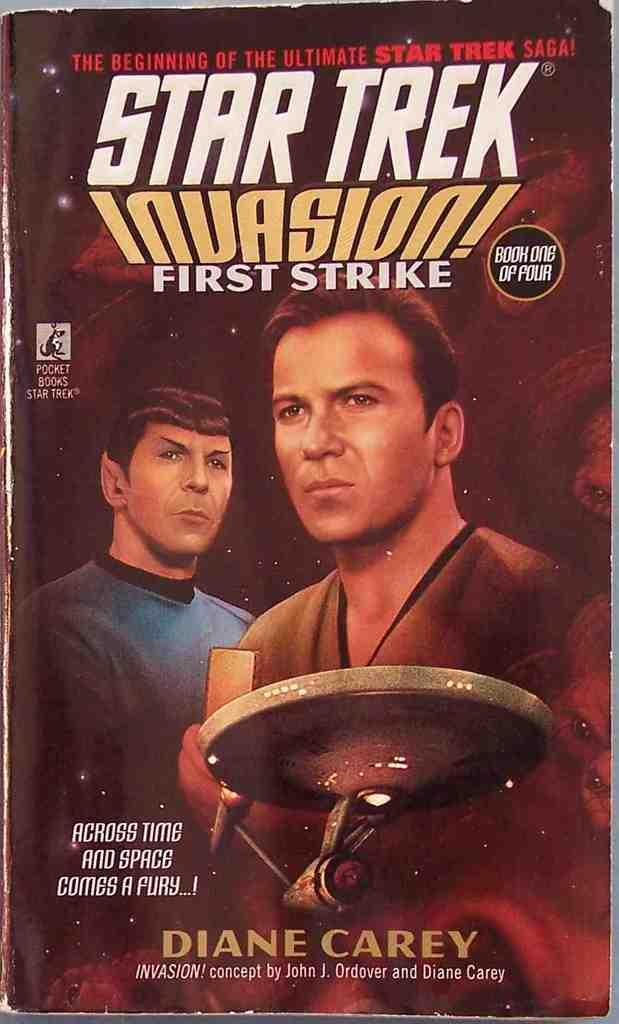What is the main subject of the image? The main subject of the image is a paper. What is depicted on the paper? The paper has a print of two persons wearing different color dresses. What text is written on the paper? The text "Star Trek Invasion" is written on the paper. What type of whip is being used by the person in the image? There is no whip present in the image; it features a paper with a print of two persons wearing different color dresses and the text "Star Trek Invasion." Who is the partner of the person in the image? The image does not depict a partnership or relationship between the two persons; it only shows their printed image on the paper. 